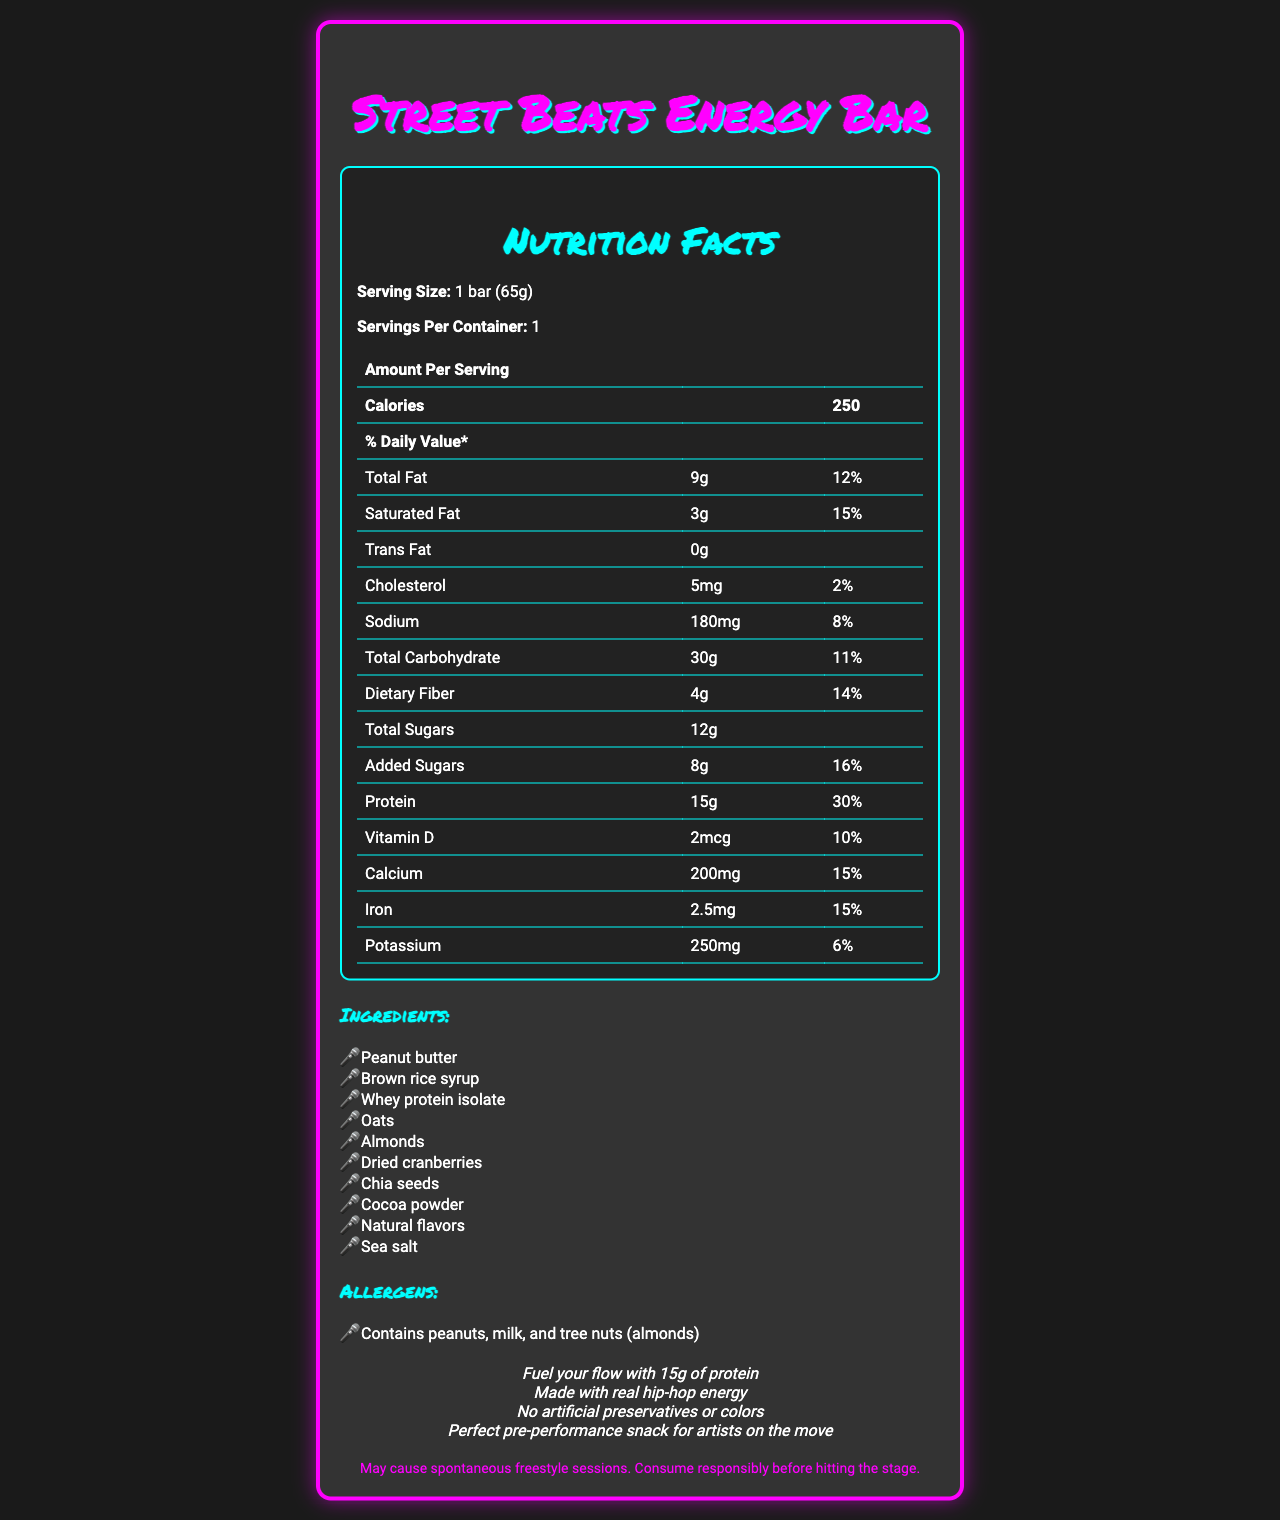what is the serving size of the Street Beats Energy Bar? The serving size is clearly listed as "1 bar (65g)" in the document.
Answer: 1 bar (65g) how many servings per container are there? The document indicates that there is 1 serving per container.
Answer: 1 how many grams of protein are in one serving? The nutrition facts list the amount of protein as "15g" per serving.
Answer: 15g name two key ingredients in the Street Beats Energy Bar. The ingredients include "Peanut butter" and "Brown rice syrup" among others.
Answer: Peanut butter, Brown rice syrup what is the daily value percentage of calcium in one serving? The calcium content is listed as 200mg, which corresponds to 15% of the daily value.
Answer: 15% how many calories are in one serving of the Street Beats Energy Bar? The document shows that one serving contains 250 calories.
Answer: 250 what is the flavor name of this energy bar? The rapper-inspired flavor name is "Lyrical Lemon Zest Crunch".
Answer: Lyrical Lemon Zest Crunch how much added sugars does the Street Beats Energy Bar contain? The nutrition facts state that the bar contains 8g of added sugars.
Answer: 8g which of the following is NOT an ingredient in the Street Beats Energy Bar? A. Chia seeds B. Almonds C. Soy protein The listed ingredients include Chia seeds and Almonds, but Soy protein is not mentioned.
Answer: C what is the amount of sodium in one serving? A. 180mg B. 200mg C. 250mg D. 300mg The sodium content per serving is 180mg.
Answer: A is the product labeled with a marketing claim about artificial preservatives or colors? One of the marketing claims states "No artificial preservatives or colors."
Answer: Yes does this product contain any tree nuts? The allergens section mentions that the product contains tree nuts (almonds).
Answer: Yes summarize the main features of the Street Beats Energy Bar. The summary encapsulates the product's purpose, design, nutritional content, ingredients, and key marketing points, giving a comprehensive overview of the Street Beats Energy Bar.
Answer: The Street Beats Energy Bar is designed for pre-performance fueling, featuring bold graffiti-style graphics. It has a rapper-inspired flavor named "Lyrical Lemon Zest Crunch" and provides 250 calories, 15g of protein, and 30g of carbohydrates per serving. The bar contains ingredients like peanut butter, brown rice syrup, and whey protein isolate. It is free from artificial preservatives and colors and contains allergens like peanuts, milk, and tree nuts. Marketing claims highlight its suitability as a pre-performance snack for artists on the move. what are the potential allergens listed for this product? The document indicates that the product contains peanuts, milk, and tree nuts (almonds).
Answer: Peanuts, milk, and tree nuts (almonds) what is the purpose of the disclaimer at the end of the document? The document provides a disclaimer that is music-related, but it does not specify the exact purpose or the reason behind the disclaimer.
Answer: Cannot be determined how much dietary fiber is in one serving? The nutrition facts list the dietary fiber content as 4g per serving.
Answer: 4g 